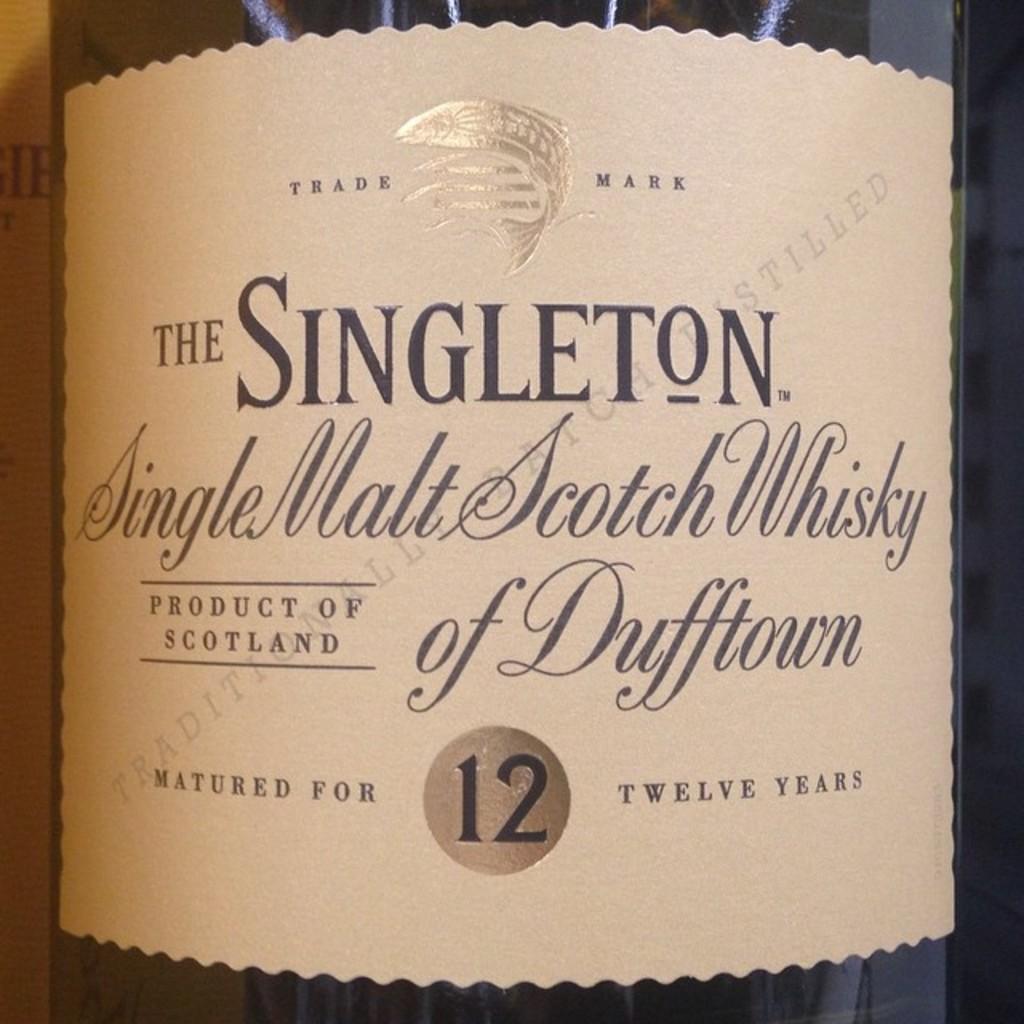Who makes this whisky?
Give a very brief answer. Singleton. 